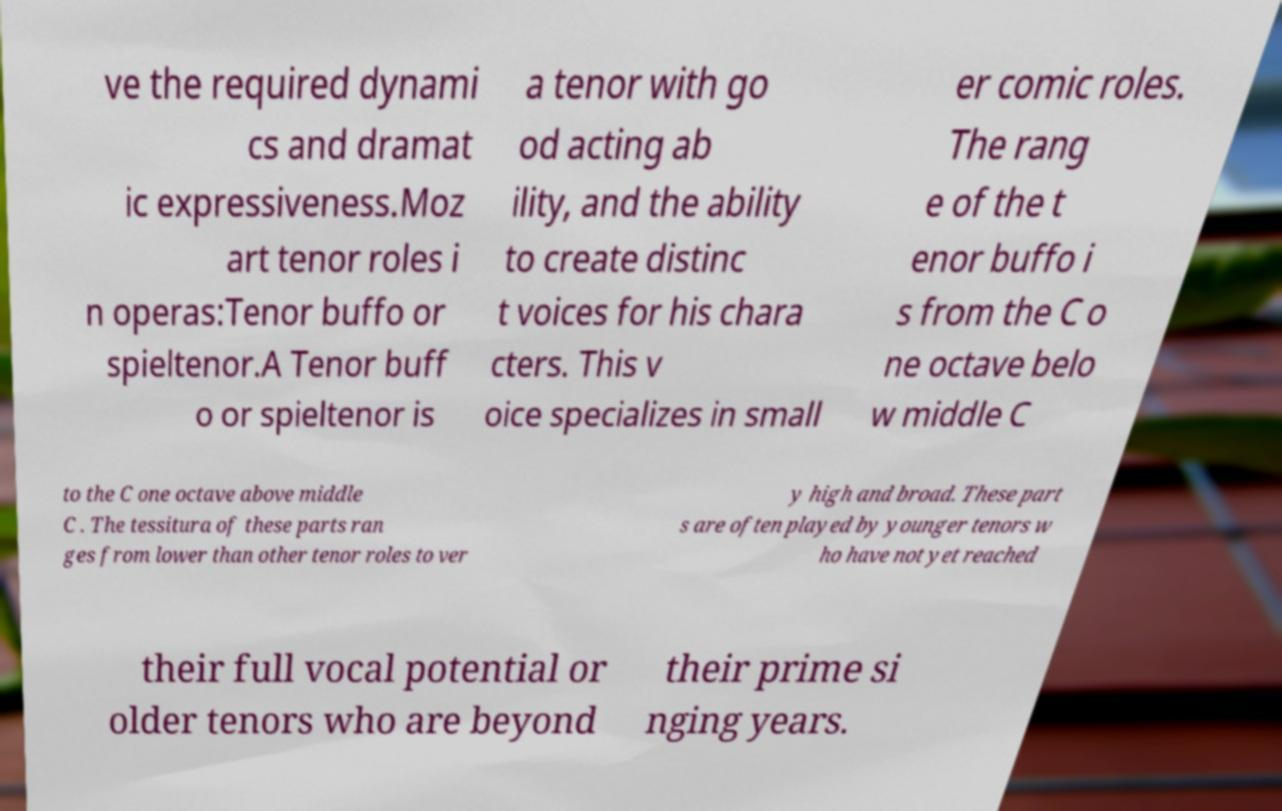Can you read and provide the text displayed in the image?This photo seems to have some interesting text. Can you extract and type it out for me? ve the required dynami cs and dramat ic expressiveness.Moz art tenor roles i n operas:Tenor buffo or spieltenor.A Tenor buff o or spieltenor is a tenor with go od acting ab ility, and the ability to create distinc t voices for his chara cters. This v oice specializes in small er comic roles. The rang e of the t enor buffo i s from the C o ne octave belo w middle C to the C one octave above middle C . The tessitura of these parts ran ges from lower than other tenor roles to ver y high and broad. These part s are often played by younger tenors w ho have not yet reached their full vocal potential or older tenors who are beyond their prime si nging years. 